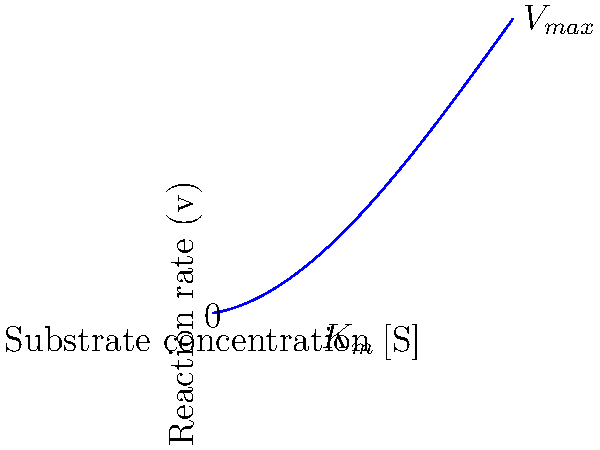The graph above represents the relationship between substrate concentration [S] and reaction rate (v) for an enzyme-catalyzed reaction. The curve follows a polynomial function rather than the typical Michaelis-Menten hyperbola. Based on this graph, what can you conclude about the enzyme's behavior, and how does it differ from standard Michaelis-Menten kinetics? To analyze this enzyme's behavior, let's examine the graph step-by-step:

1. Shape of the curve: The curve is not a hyperbola as in standard Michaelis-Menten kinetics. Instead, it's a polynomial function, specifically a cubic function (degree 3).

2. Initial behavior: At low substrate concentrations, the reaction rate increases rapidly, similar to Michaelis-Menten kinetics.

3. Middle region: The curve shows a more gradual increase in reaction rate as substrate concentration increases, unlike the sharp approach to $V_{max}$ in Michaelis-Menten kinetics.

4. High substrate concentrations: The reaction rate continues to increase beyond what would be $V_{max}$ in standard kinetics. This suggests substrate activation.

5. No clear $V_{max}$: There's no apparent plateau, indicating that the reaction rate doesn't reach a maximum value within the given substrate concentration range.

6. $K_m$ approximation: The substrate concentration at half the maximum rate observed (not true $V_{max}$) is marked on the x-axis, but its meaning is less clear in this non-standard kinetics.

This behavior suggests:
a) Positive cooperativity: The enzyme might have multiple binding sites that interact positively, increasing affinity as more substrate binds.
b) Substrate activation: Higher substrate concentrations continue to increase the reaction rate, possibly by altering the enzyme's conformation or creating additional active sites.
c) Allosteric effects: The substrate might bind to sites other than the active site, modifying the enzyme's activity.

These characteristics deviate significantly from standard Michaelis-Menten kinetics, which assumes a single substrate binding site, no cooperativity, and a clear $V_{max}$.
Answer: The enzyme exhibits positive cooperativity and substrate activation, deviating from Michaelis-Menten kinetics. 